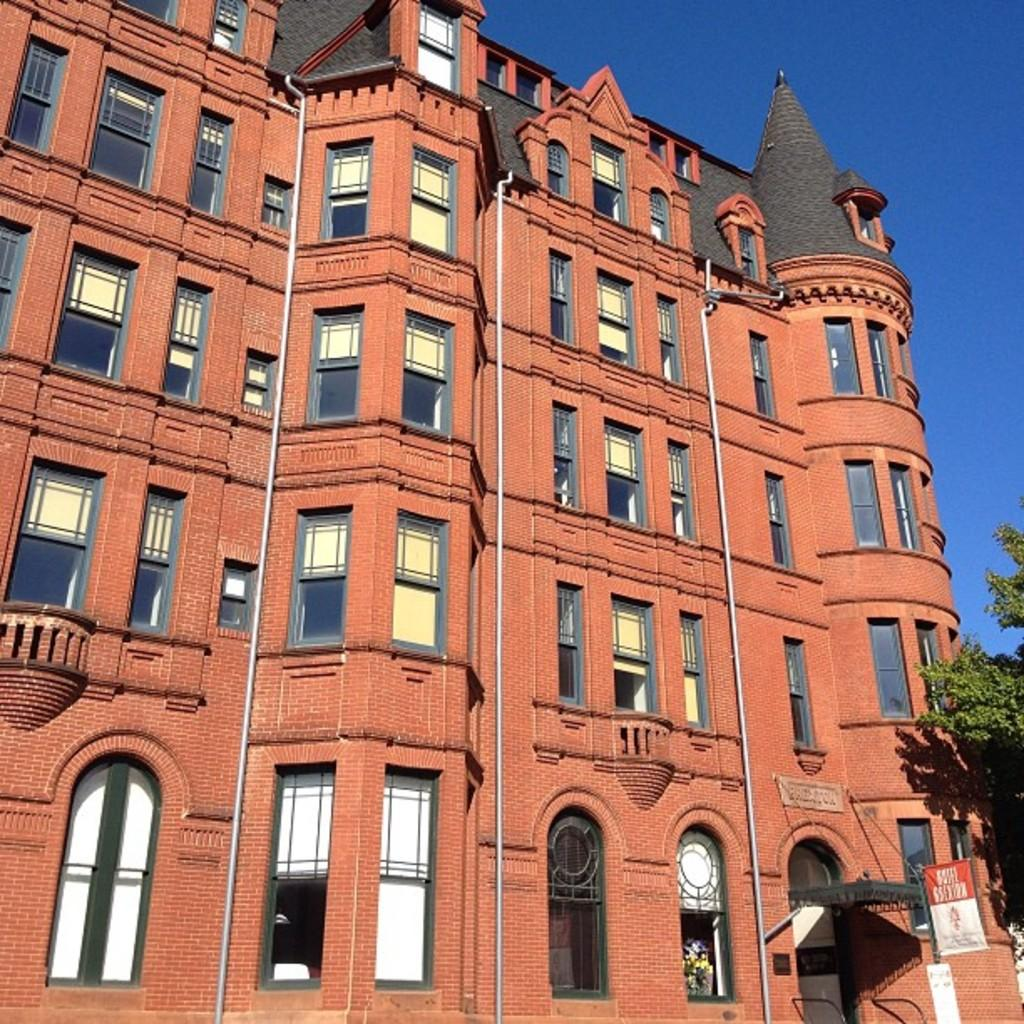What type of structure is present in the image? There is a building in the image. What features can be observed on the building? The building has windows and pipes. What other objects are present in the image besides the building? There is a tree, a poster, and other objects in the image. What can be seen in the background of the image? The sky is visible in the background of the image. How does the building measure the temperature in the image? The building does not measure the temperature in the image; there is no indication of any temperature-measuring devices. 